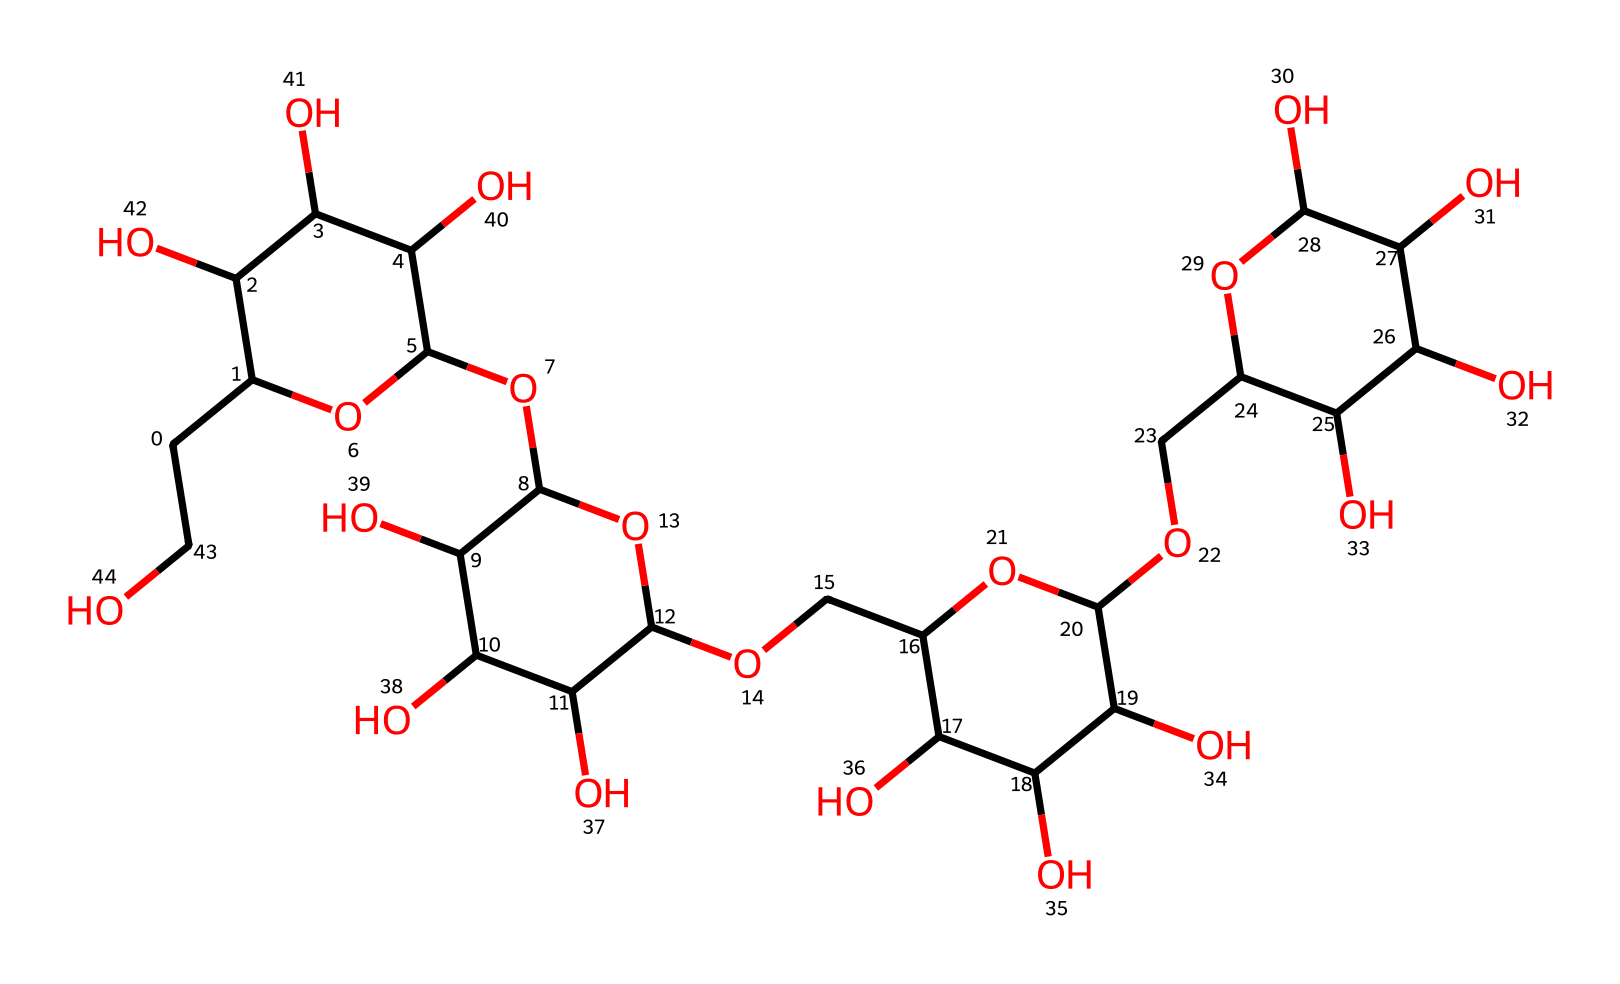What is the molecular formula of glycogen represented in this SMILES? By analyzing the SMILES representation, we can deduce the composition of glycogen by counting the carbon (C), hydrogen (H), and oxygen (O) atoms. The presence of multiple rings indicates a carbohydrate structure, specifically polysaccharides like glycogen. Counting the atoms shows that the molecular formula is C24H42O21.
Answer: C24H42O21 How many monomer units are present in this glycogen structure? In the SMILES representation, the presence of branching and multiple glucose units indicates that glycogen is made up of repeated glucose monomers. Each glucose unit is represented by a specific pattern. By counting the distinct glucose patterns, we find that there are approximately five monomer units linked together.
Answer: five What type of carbohydrate is represented in this structure? The structure depicted in the SMILES shows a polysaccharide due to its multiple glucose units and branch points, characteristic of storage carbohydrates. Specifically, glycogen is an energy storage polysaccharide synthesized primarily in animals.
Answer: polysaccharide How does this glycogen structure facilitate muscle energy storage? The branching structure of glycogen allows for rapid mobilization of glucose during high-energy demands, particularly during muscle contraction in high-G maneuvers. The multiple terminals available in the branching enable quick enzymatic action, facilitating faster energy release.
Answer: branching What are the functional groups present in this glycogen structure? Observing the SMILES representation, we can identify alcohol (-OH) functional groups which are prominent due to the hydroxyl groups off the carbon backbone. These hydroxyl groups are critical for the solubility and reactivity of glycogen in biological systems.
Answer: alcohol groups 